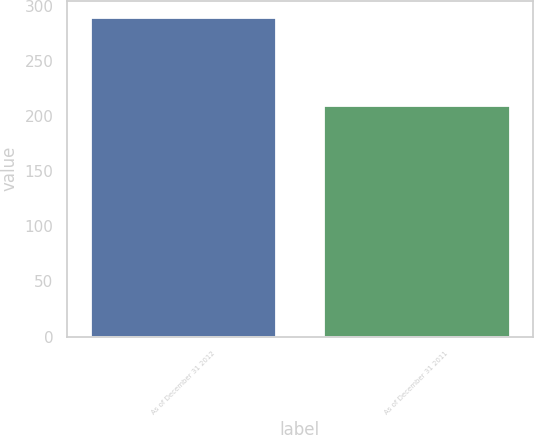Convert chart to OTSL. <chart><loc_0><loc_0><loc_500><loc_500><bar_chart><fcel>As of December 31 2012<fcel>As of December 31 2011<nl><fcel>290<fcel>210<nl></chart> 